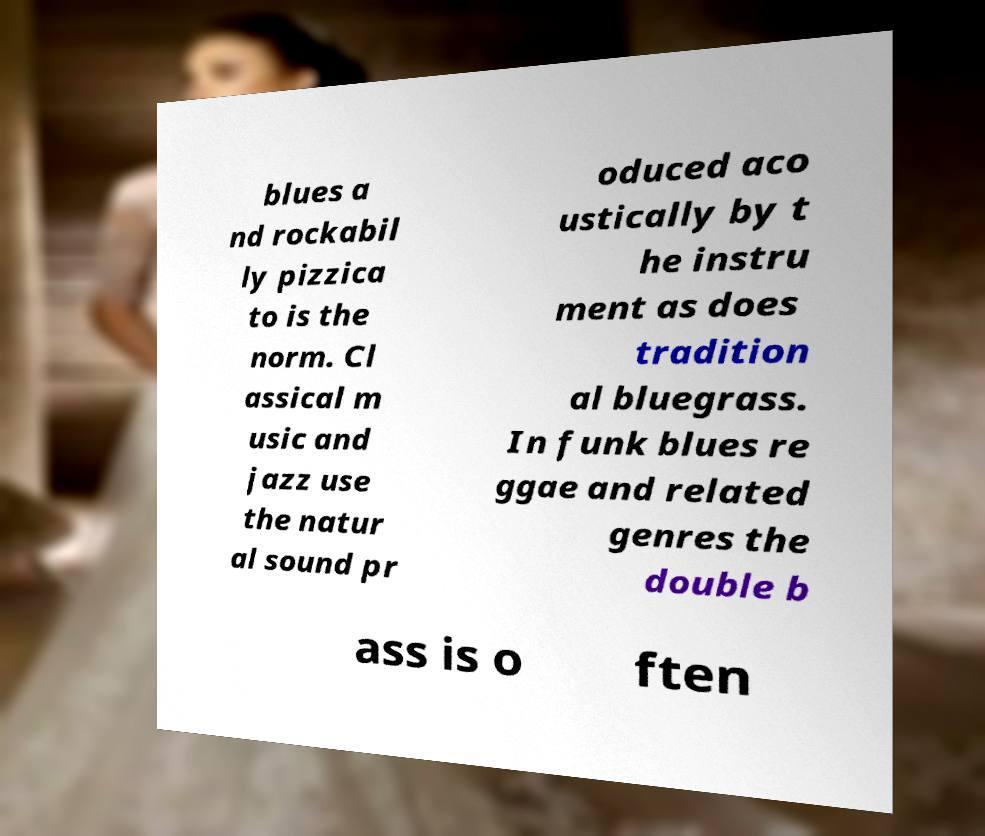Please read and relay the text visible in this image. What does it say? blues a nd rockabil ly pizzica to is the norm. Cl assical m usic and jazz use the natur al sound pr oduced aco ustically by t he instru ment as does tradition al bluegrass. In funk blues re ggae and related genres the double b ass is o ften 